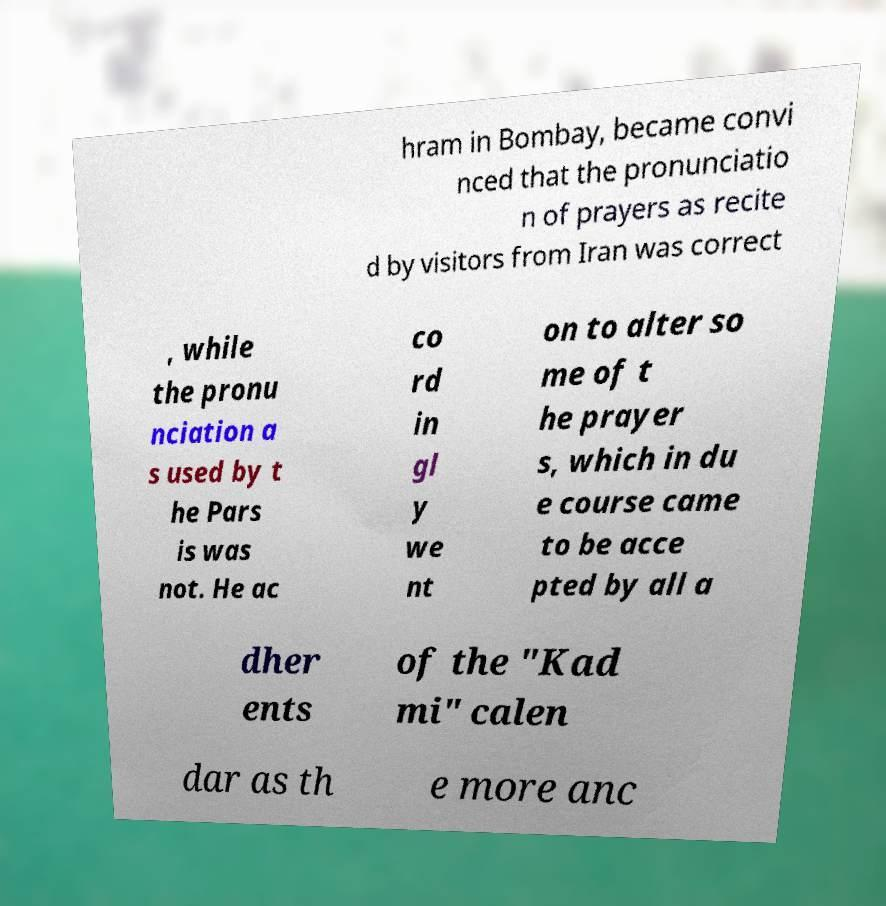For documentation purposes, I need the text within this image transcribed. Could you provide that? hram in Bombay, became convi nced that the pronunciatio n of prayers as recite d by visitors from Iran was correct , while the pronu nciation a s used by t he Pars is was not. He ac co rd in gl y we nt on to alter so me of t he prayer s, which in du e course came to be acce pted by all a dher ents of the "Kad mi" calen dar as th e more anc 